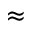<formula> <loc_0><loc_0><loc_500><loc_500>\approx</formula> 